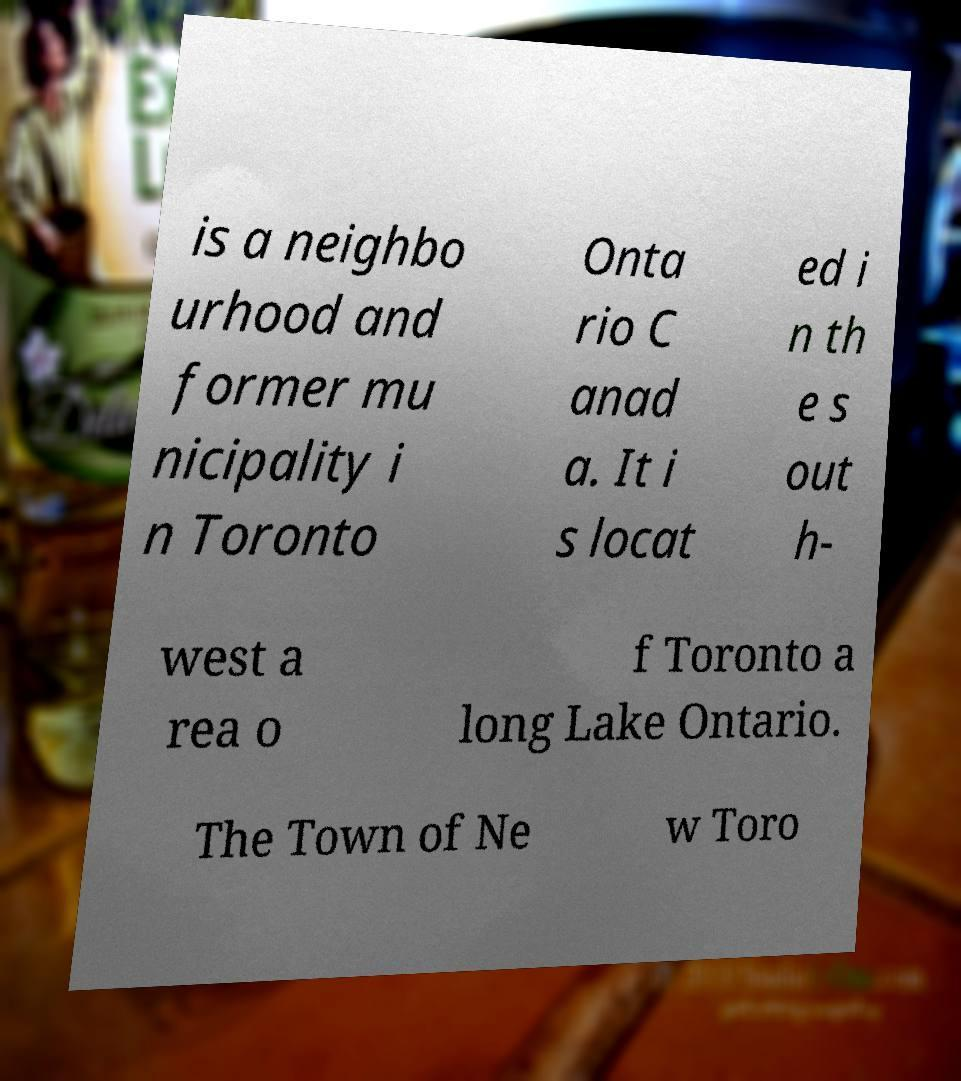Can you accurately transcribe the text from the provided image for me? is a neighbo urhood and former mu nicipality i n Toronto Onta rio C anad a. It i s locat ed i n th e s out h- west a rea o f Toronto a long Lake Ontario. The Town of Ne w Toro 